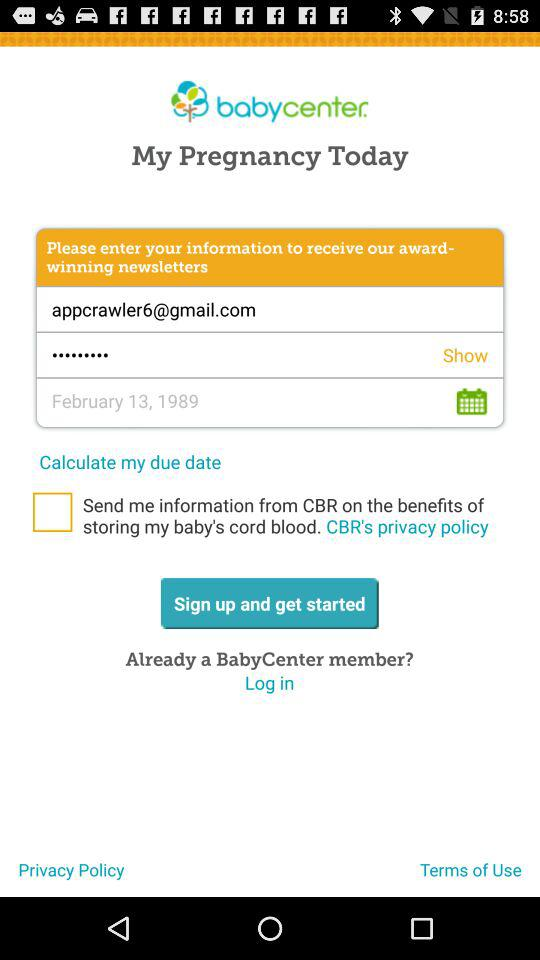What is the application name? The application name is "babycenter". 